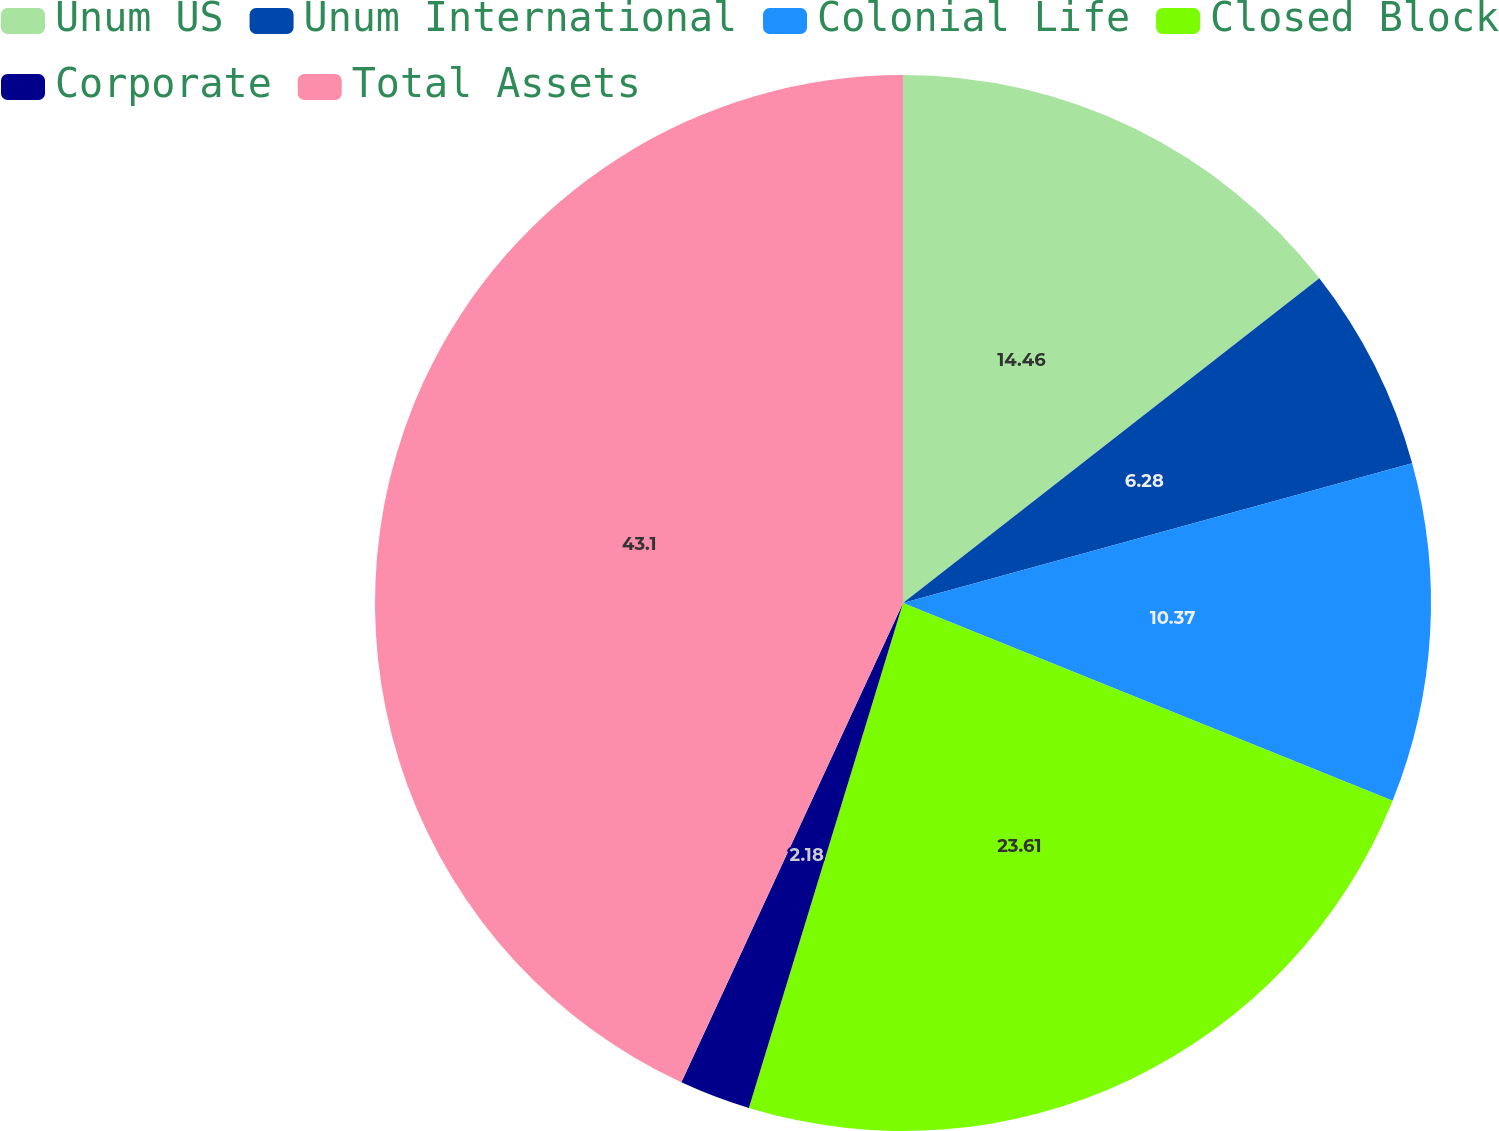Convert chart. <chart><loc_0><loc_0><loc_500><loc_500><pie_chart><fcel>Unum US<fcel>Unum International<fcel>Colonial Life<fcel>Closed Block<fcel>Corporate<fcel>Total Assets<nl><fcel>14.46%<fcel>6.28%<fcel>10.37%<fcel>23.61%<fcel>2.18%<fcel>43.11%<nl></chart> 